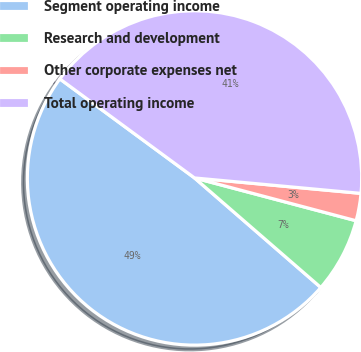Convert chart. <chart><loc_0><loc_0><loc_500><loc_500><pie_chart><fcel>Segment operating income<fcel>Research and development<fcel>Other corporate expenses net<fcel>Total operating income<nl><fcel>48.72%<fcel>7.25%<fcel>2.65%<fcel>41.38%<nl></chart> 